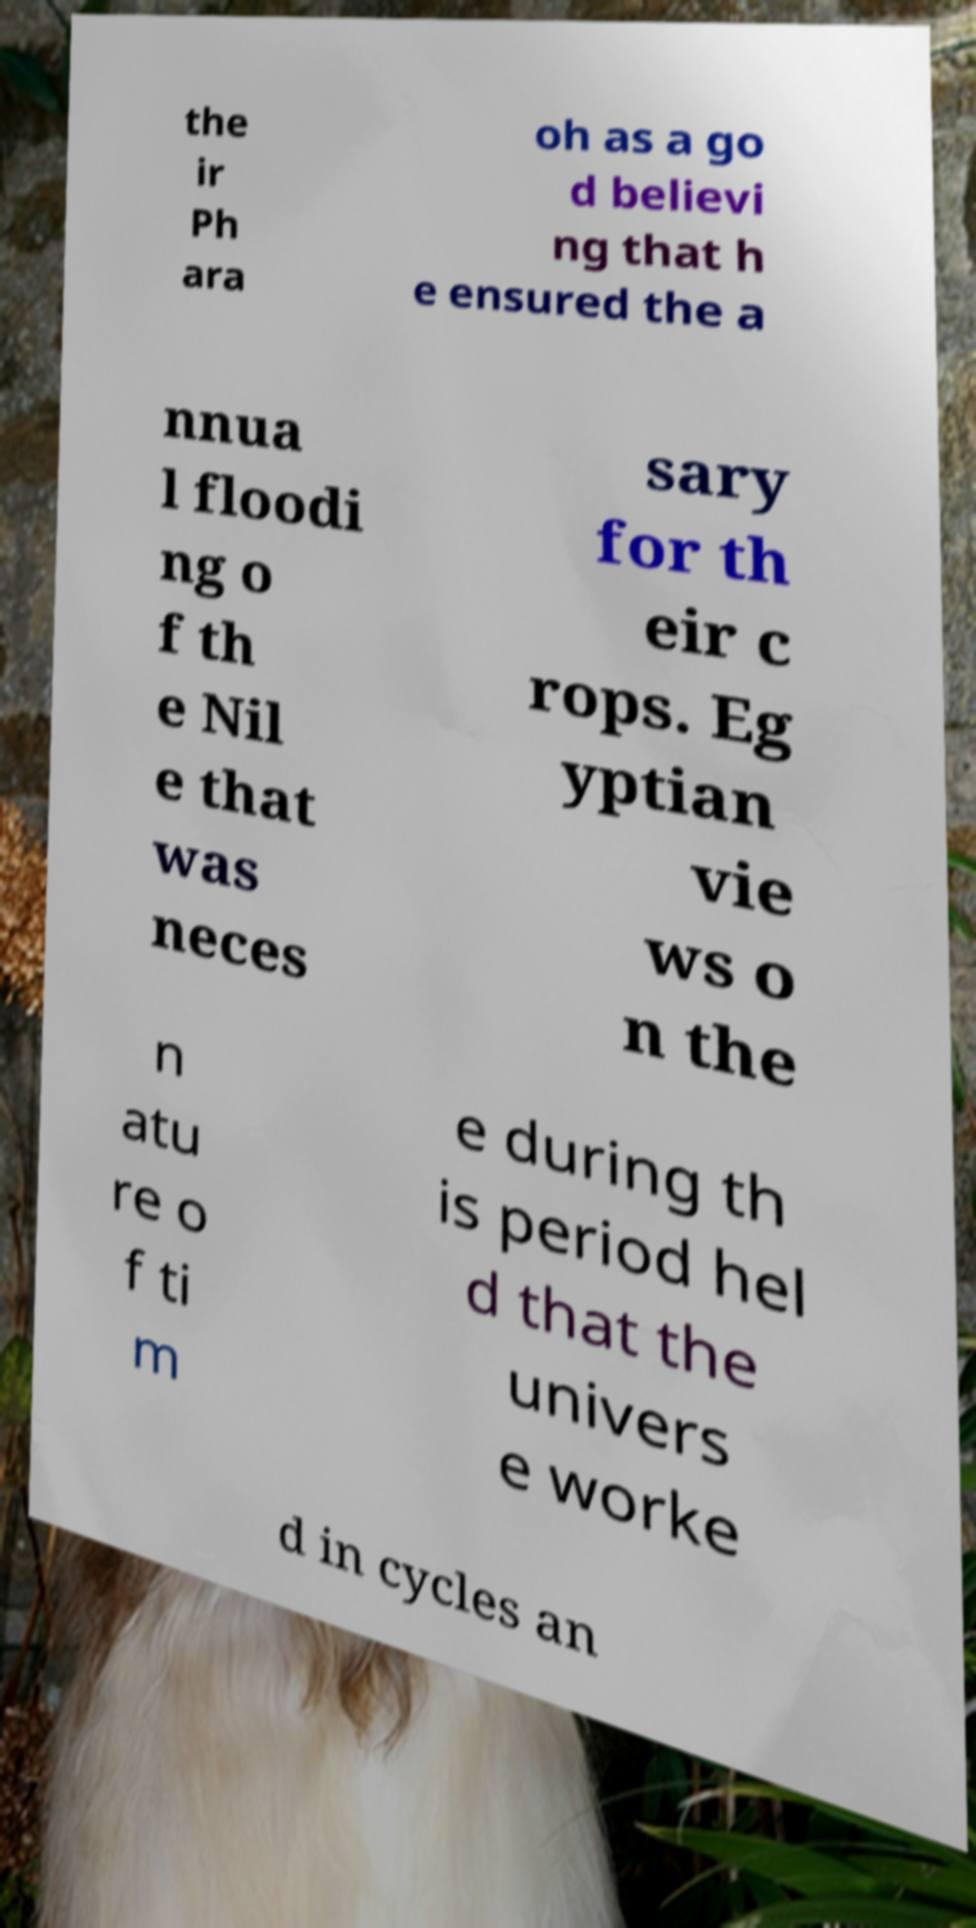There's text embedded in this image that I need extracted. Can you transcribe it verbatim? the ir Ph ara oh as a go d believi ng that h e ensured the a nnua l floodi ng o f th e Nil e that was neces sary for th eir c rops. Eg yptian vie ws o n the n atu re o f ti m e during th is period hel d that the univers e worke d in cycles an 